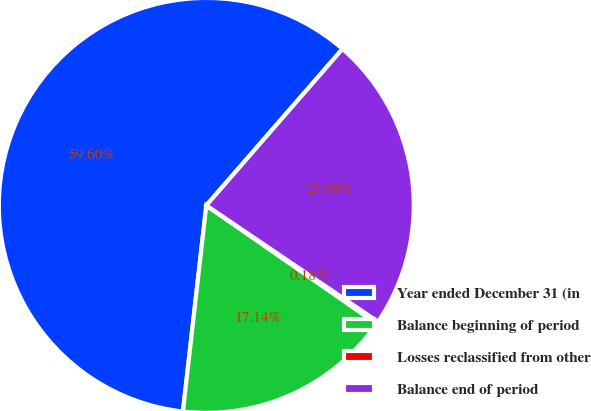<chart> <loc_0><loc_0><loc_500><loc_500><pie_chart><fcel>Year ended December 31 (in<fcel>Balance beginning of period<fcel>Losses reclassified from other<fcel>Balance end of period<nl><fcel>59.6%<fcel>17.14%<fcel>0.18%<fcel>23.08%<nl></chart> 